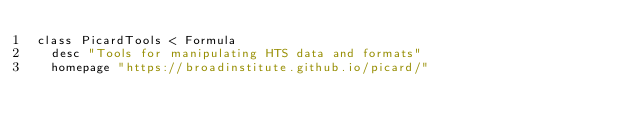Convert code to text. <code><loc_0><loc_0><loc_500><loc_500><_Ruby_>class PicardTools < Formula
  desc "Tools for manipulating HTS data and formats"
  homepage "https://broadinstitute.github.io/picard/"</code> 